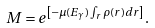<formula> <loc_0><loc_0><loc_500><loc_500>M = e ^ { \left [ - \mu ( E _ { \gamma } ) \int _ { r } \rho ( r ) d r \right ] } .</formula> 